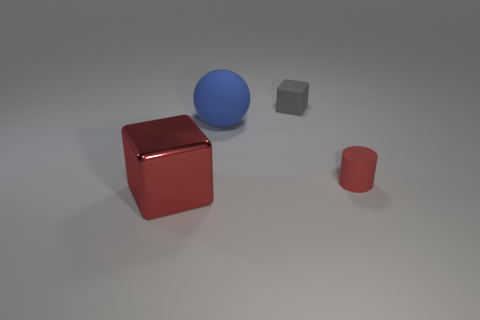The shiny block that is the same color as the rubber cylinder is what size?
Keep it short and to the point. Large. There is another thing that is the same color as the big metallic object; what is its material?
Your answer should be compact. Rubber. Do the sphere and the gray object have the same size?
Your response must be concise. No. How many small red cylinders have the same material as the large ball?
Ensure brevity in your answer.  1. There is a object that is left of the small matte cylinder and in front of the large blue ball; what shape is it?
Your answer should be very brief. Cube. How many things are either cubes that are on the right side of the blue object or rubber things that are behind the red rubber thing?
Your answer should be very brief. 2. Is the number of tiny gray things that are to the left of the tiny gray matte cube the same as the number of large objects right of the red shiny cube?
Your response must be concise. No. What is the shape of the small rubber object that is in front of the large object that is behind the red rubber cylinder?
Provide a short and direct response. Cylinder. Is there a large thing of the same shape as the tiny gray matte object?
Your response must be concise. Yes. What number of red matte objects are there?
Provide a succinct answer. 1. 